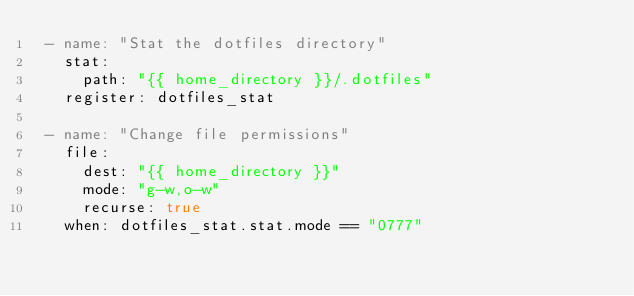Convert code to text. <code><loc_0><loc_0><loc_500><loc_500><_YAML_> - name: "Stat the dotfiles directory"
   stat:
     path: "{{ home_directory }}/.dotfiles"
   register: dotfiles_stat

 - name: "Change file permissions"
   file:
     dest: "{{ home_directory }}"
     mode: "g-w,o-w"
     recurse: true
   when: dotfiles_stat.stat.mode == "0777"

</code> 